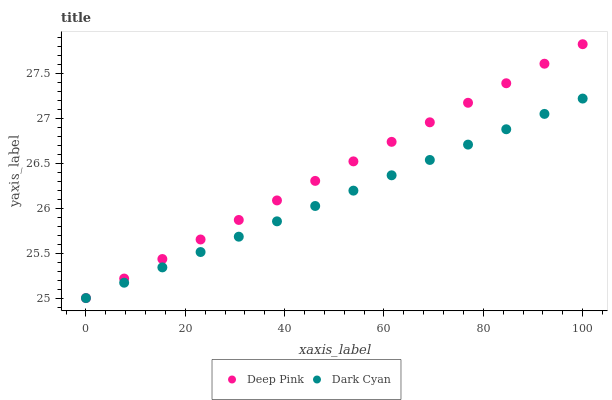Does Dark Cyan have the minimum area under the curve?
Answer yes or no. Yes. Does Deep Pink have the maximum area under the curve?
Answer yes or no. Yes. Does Deep Pink have the minimum area under the curve?
Answer yes or no. No. Is Dark Cyan the smoothest?
Answer yes or no. Yes. Is Deep Pink the roughest?
Answer yes or no. Yes. Is Deep Pink the smoothest?
Answer yes or no. No. Does Dark Cyan have the lowest value?
Answer yes or no. Yes. Does Deep Pink have the highest value?
Answer yes or no. Yes. Does Deep Pink intersect Dark Cyan?
Answer yes or no. Yes. Is Deep Pink less than Dark Cyan?
Answer yes or no. No. Is Deep Pink greater than Dark Cyan?
Answer yes or no. No. 